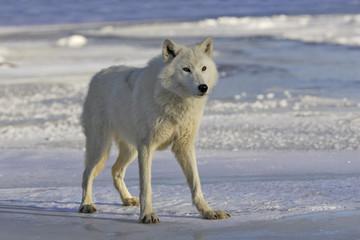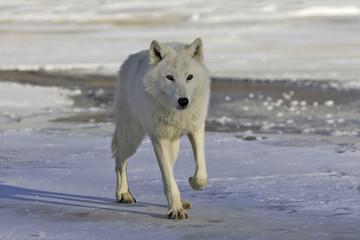The first image is the image on the left, the second image is the image on the right. Assess this claim about the two images: "A dog has its mouth open.". Correct or not? Answer yes or no. No. The first image is the image on the left, the second image is the image on the right. Considering the images on both sides, is "There is a single white wolf in each of the images." valid? Answer yes or no. Yes. 